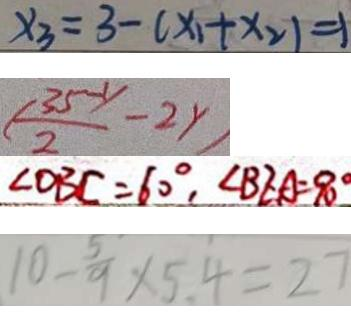<formula> <loc_0><loc_0><loc_500><loc_500>x _ { 3 } = 3 - ( x _ { 1 } + x _ { 2 } ) = 1 
 ( \frac { 3 5 - y } { 2 } - 2 y ) 
 \angle O B C = 6 0 ^ { \circ } , \angle B E A = 9 0 ^ { \circ } 
 1 0 - \frac { 5 } { 9 } \times 5 . 4 = 2 7</formula> 